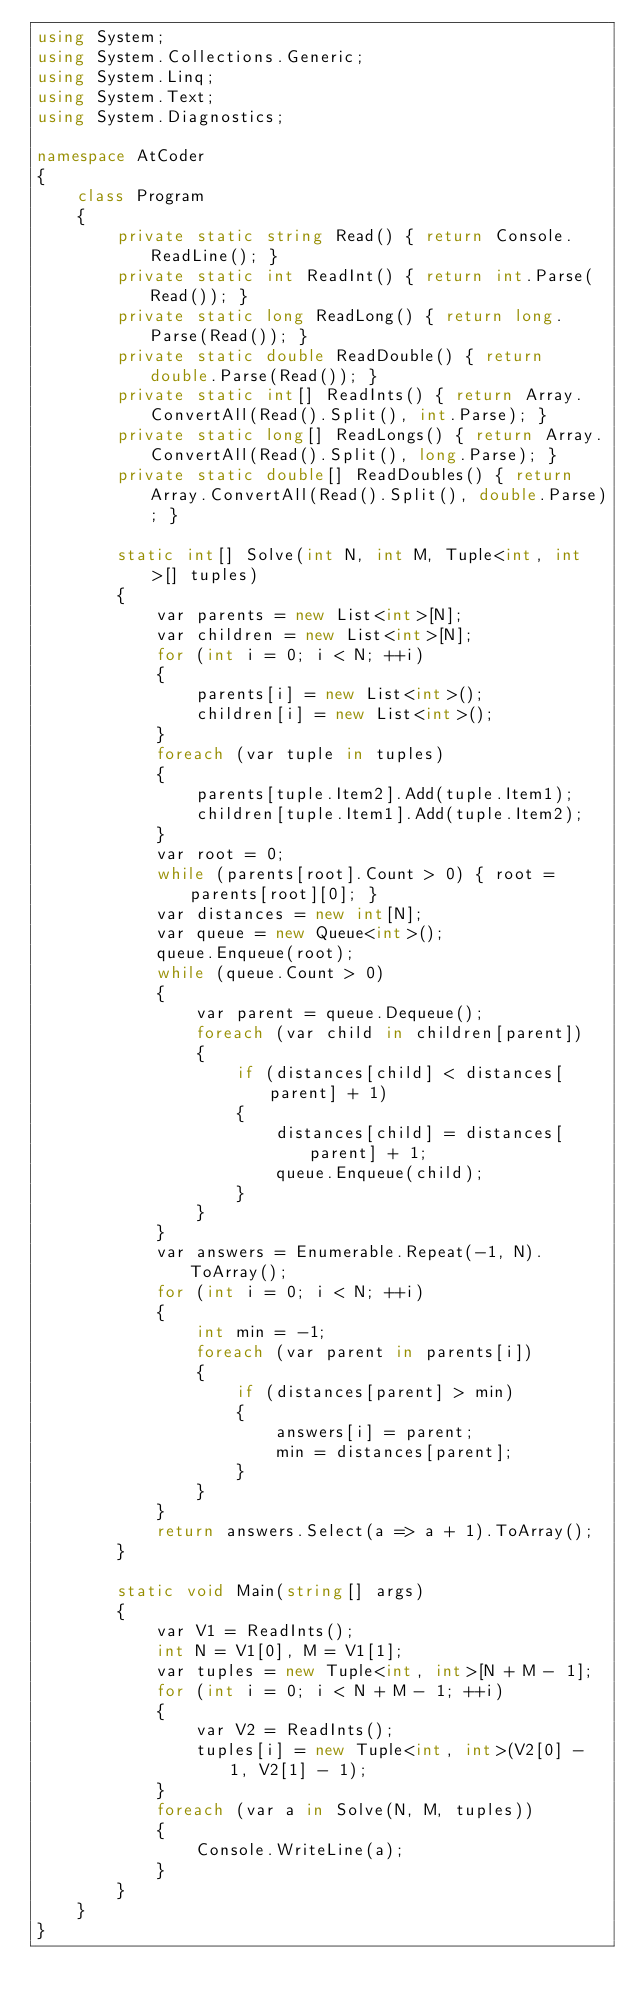<code> <loc_0><loc_0><loc_500><loc_500><_C#_>using System;
using System.Collections.Generic;
using System.Linq;
using System.Text;
using System.Diagnostics;

namespace AtCoder
{
    class Program
    {
        private static string Read() { return Console.ReadLine(); }
        private static int ReadInt() { return int.Parse(Read()); }
        private static long ReadLong() { return long.Parse(Read()); }
        private static double ReadDouble() { return double.Parse(Read()); }
        private static int[] ReadInts() { return Array.ConvertAll(Read().Split(), int.Parse); }
        private static long[] ReadLongs() { return Array.ConvertAll(Read().Split(), long.Parse); }
        private static double[] ReadDoubles() { return Array.ConvertAll(Read().Split(), double.Parse); }

        static int[] Solve(int N, int M, Tuple<int, int>[] tuples)
        {
            var parents = new List<int>[N];
            var children = new List<int>[N];
            for (int i = 0; i < N; ++i)
            {
                parents[i] = new List<int>();
                children[i] = new List<int>();
            }
            foreach (var tuple in tuples)
            {
                parents[tuple.Item2].Add(tuple.Item1);
                children[tuple.Item1].Add(tuple.Item2);
            }
            var root = 0;
            while (parents[root].Count > 0) { root = parents[root][0]; }
            var distances = new int[N];
            var queue = new Queue<int>();
            queue.Enqueue(root);
            while (queue.Count > 0)
            {
                var parent = queue.Dequeue();
                foreach (var child in children[parent])
                {
                    if (distances[child] < distances[parent] + 1)
                    {
                        distances[child] = distances[parent] + 1;
                        queue.Enqueue(child);
                    }
                }
            }
            var answers = Enumerable.Repeat(-1, N).ToArray();
            for (int i = 0; i < N; ++i)
            {
                int min = -1;
                foreach (var parent in parents[i])
                {
                    if (distances[parent] > min)
                    {
                        answers[i] = parent;
                        min = distances[parent];
                    }
                }
            }
            return answers.Select(a => a + 1).ToArray();
        }

        static void Main(string[] args)
        {
            var V1 = ReadInts();
            int N = V1[0], M = V1[1];
            var tuples = new Tuple<int, int>[N + M - 1];
            for (int i = 0; i < N + M - 1; ++i)
            {
                var V2 = ReadInts();
                tuples[i] = new Tuple<int, int>(V2[0] - 1, V2[1] - 1);
            }
            foreach (var a in Solve(N, M, tuples))
            {
                Console.WriteLine(a);
            }
        }
    }
}
</code> 